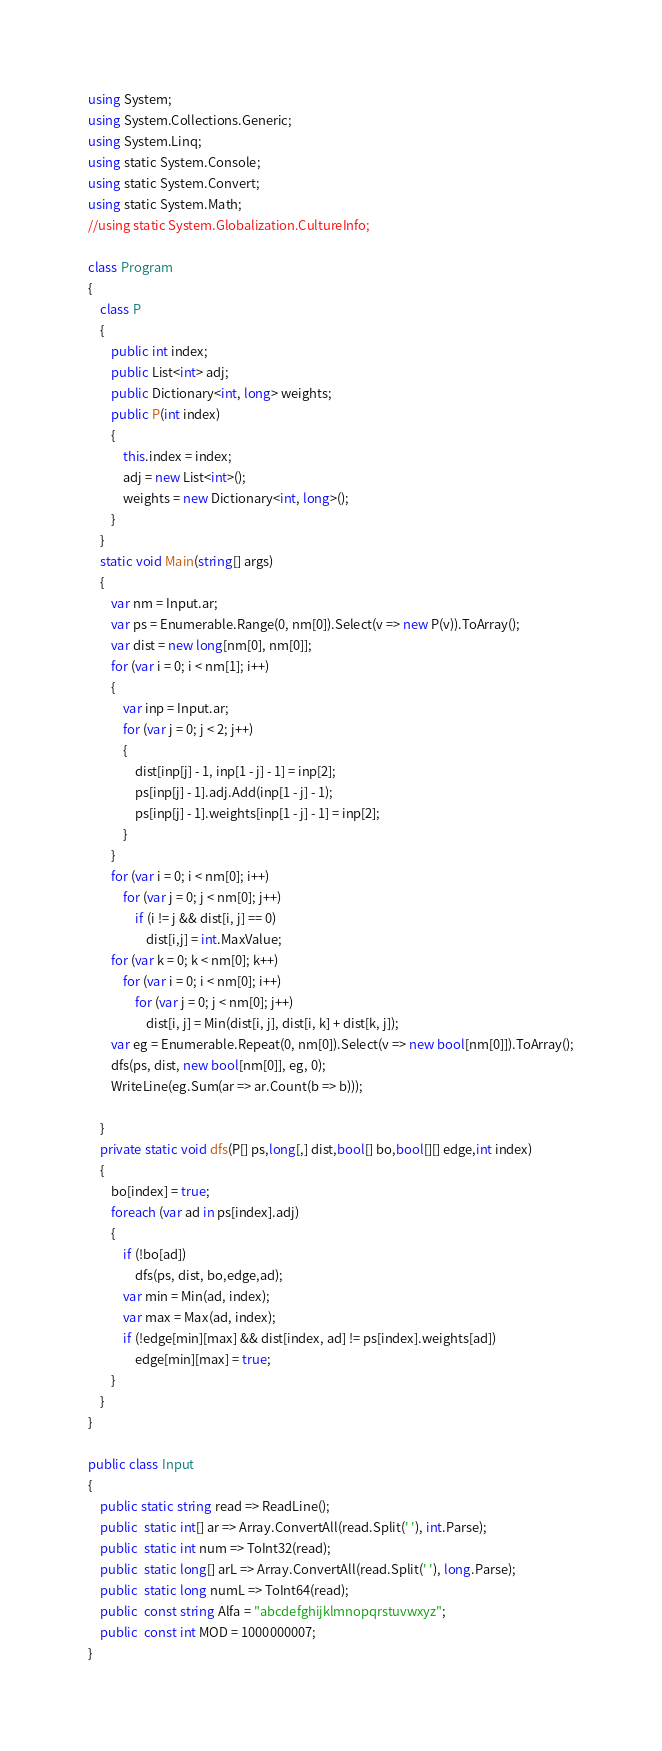<code> <loc_0><loc_0><loc_500><loc_500><_C#_>using System;
using System.Collections.Generic;
using System.Linq;
using static System.Console;
using static System.Convert;
using static System.Math;
//using static System.Globalization.CultureInfo;

class Program
{
    class P
    {
        public int index;
        public List<int> adj;
        public Dictionary<int, long> weights;
        public P(int index)
        {
            this.index = index;
            adj = new List<int>();
            weights = new Dictionary<int, long>();
        }
    }
    static void Main(string[] args)
    {
        var nm = Input.ar;
        var ps = Enumerable.Range(0, nm[0]).Select(v => new P(v)).ToArray();
        var dist = new long[nm[0], nm[0]];
        for (var i = 0; i < nm[1]; i++)
        {
            var inp = Input.ar;
            for (var j = 0; j < 2; j++)
            {
                dist[inp[j] - 1, inp[1 - j] - 1] = inp[2];
                ps[inp[j] - 1].adj.Add(inp[1 - j] - 1);
                ps[inp[j] - 1].weights[inp[1 - j] - 1] = inp[2];
            }
        }
        for (var i = 0; i < nm[0]; i++)
            for (var j = 0; j < nm[0]; j++)
                if (i != j && dist[i, j] == 0)
                    dist[i,j] = int.MaxValue;
        for (var k = 0; k < nm[0]; k++)
            for (var i = 0; i < nm[0]; i++)
                for (var j = 0; j < nm[0]; j++)
                    dist[i, j] = Min(dist[i, j], dist[i, k] + dist[k, j]);
        var eg = Enumerable.Repeat(0, nm[0]).Select(v => new bool[nm[0]]).ToArray();
        dfs(ps, dist, new bool[nm[0]], eg, 0);
        WriteLine(eg.Sum(ar => ar.Count(b => b)));
       
    }
    private static void dfs(P[] ps,long[,] dist,bool[] bo,bool[][] edge,int index)
    {
        bo[index] = true;
        foreach (var ad in ps[index].adj)
        {
            if (!bo[ad])
                dfs(ps, dist, bo,edge,ad);
            var min = Min(ad, index);
            var max = Max(ad, index);
            if (!edge[min][max] && dist[index, ad] != ps[index].weights[ad])
                edge[min][max] = true;
        }
    }
}

public class Input
{
    public static string read => ReadLine();
    public  static int[] ar => Array.ConvertAll(read.Split(' '), int.Parse);
    public  static int num => ToInt32(read);
    public  static long[] arL => Array.ConvertAll(read.Split(' '), long.Parse);
    public  static long numL => ToInt64(read);
    public  const string Alfa = "abcdefghijklmnopqrstuvwxyz";
    public  const int MOD = 1000000007;
}
</code> 